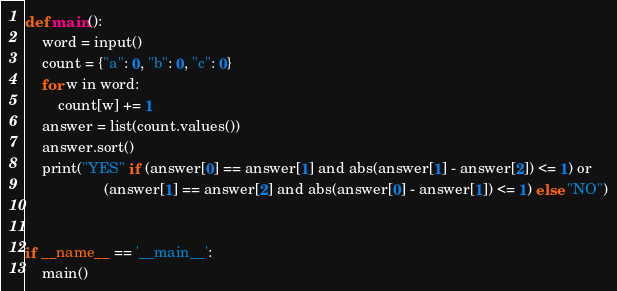<code> <loc_0><loc_0><loc_500><loc_500><_Python_>def main():
    word = input()
    count = {"a": 0, "b": 0, "c": 0}
    for w in word:
        count[w] += 1
    answer = list(count.values())
    answer.sort()
    print("YES" if (answer[0] == answer[1] and abs(answer[1] - answer[2]) <= 1) or
                   (answer[1] == answer[2] and abs(answer[0] - answer[1]) <= 1) else "NO")


if __name__ == '__main__':
    main()

</code> 